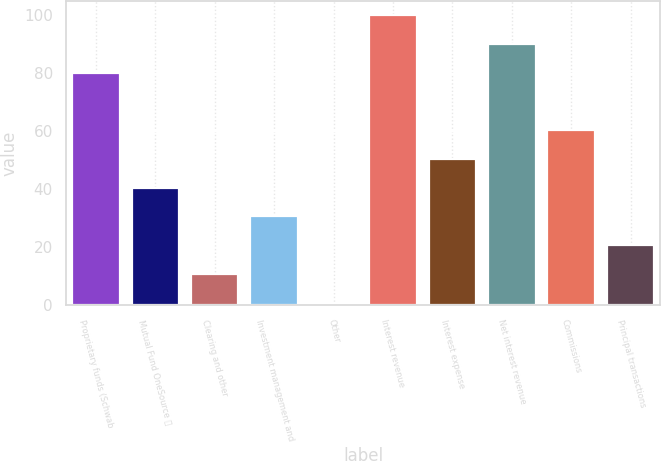Convert chart to OTSL. <chart><loc_0><loc_0><loc_500><loc_500><bar_chart><fcel>Proprietary funds (Schwab<fcel>Mutual Fund OneSource <fcel>Clearing and other<fcel>Investment management and<fcel>Other<fcel>Interest revenue<fcel>Interest expense<fcel>Net interest revenue<fcel>Commissions<fcel>Principal transactions<nl><fcel>80.2<fcel>40.6<fcel>10.9<fcel>30.7<fcel>1<fcel>100<fcel>50.5<fcel>90.1<fcel>60.4<fcel>20.8<nl></chart> 